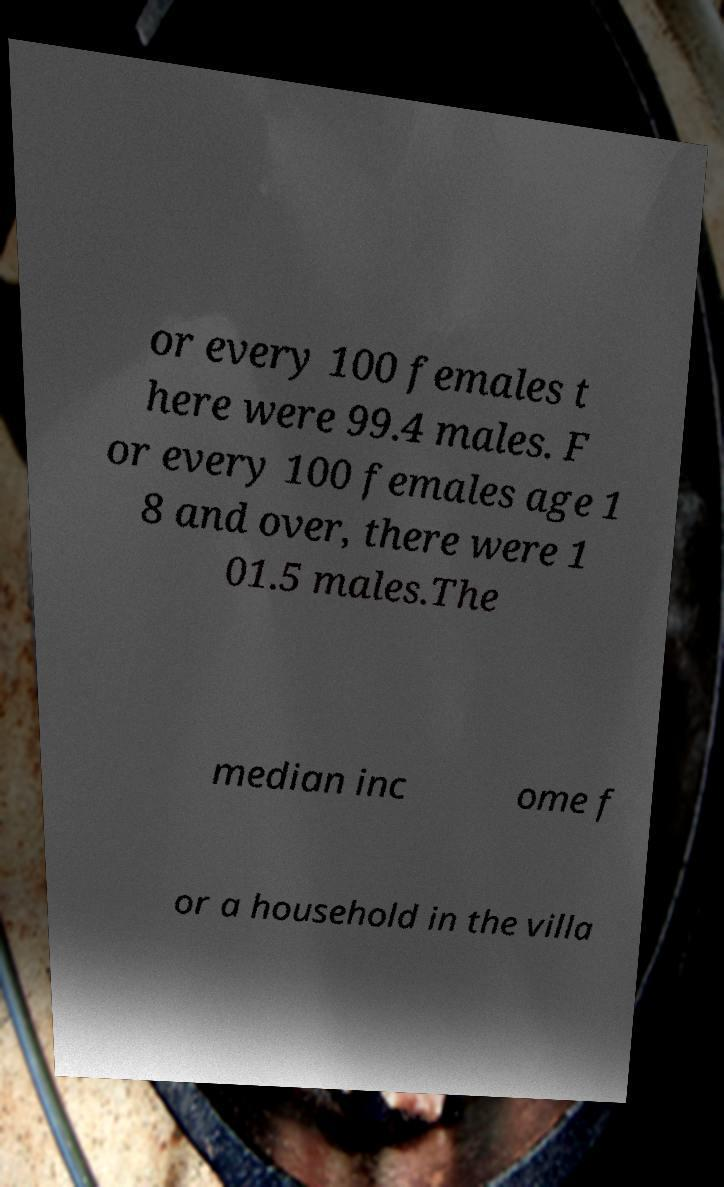Could you extract and type out the text from this image? or every 100 females t here were 99.4 males. F or every 100 females age 1 8 and over, there were 1 01.5 males.The median inc ome f or a household in the villa 